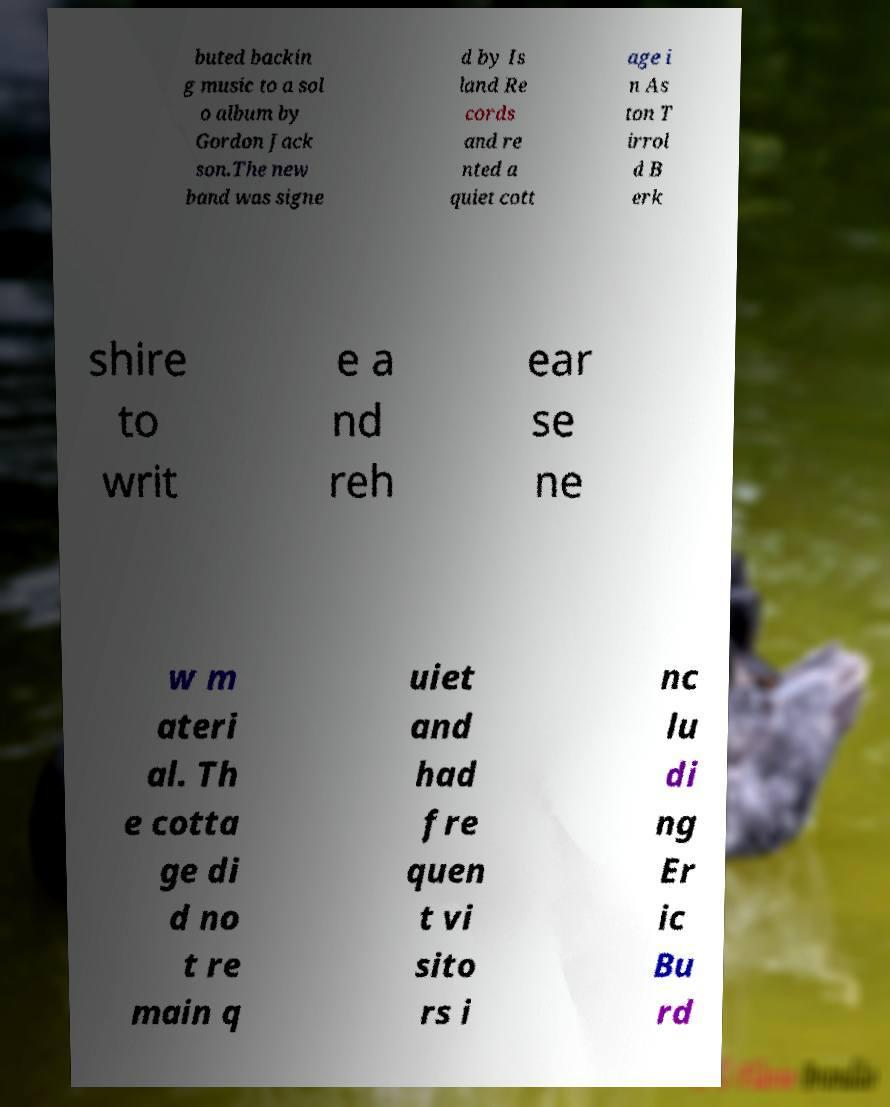Please identify and transcribe the text found in this image. buted backin g music to a sol o album by Gordon Jack son.The new band was signe d by Is land Re cords and re nted a quiet cott age i n As ton T irrol d B erk shire to writ e a nd reh ear se ne w m ateri al. Th e cotta ge di d no t re main q uiet and had fre quen t vi sito rs i nc lu di ng Er ic Bu rd 